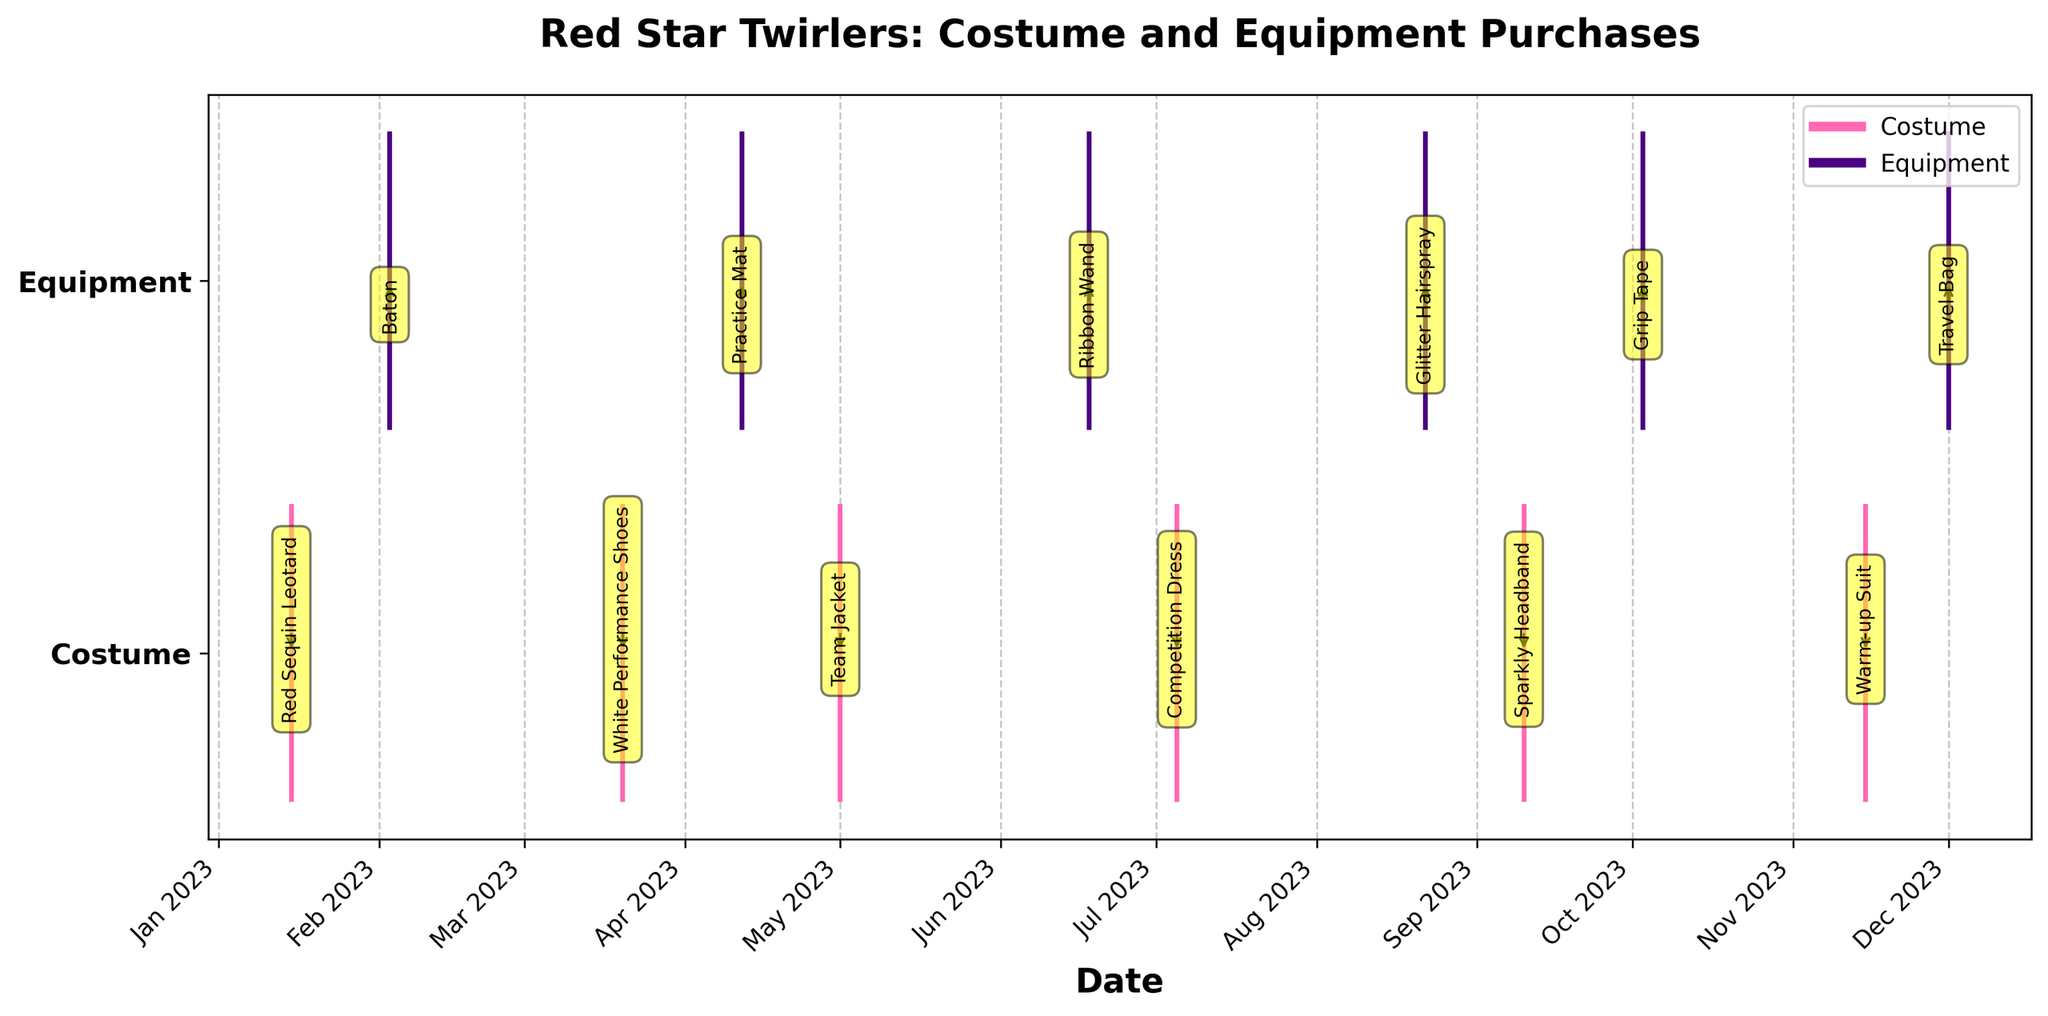What are the dates for the costume purchases? The figure shows pink vertical lines along the x-axis for costume purchases. The text annotations indicate the specific items and dates. The costume purchases occurred on January 15, March 20, May 1, July 5, September 10, and November 15.
Answer: January 15, March 20, May 1, July 5, September 10, November 15 Which category has more purchases in the year? By counting the event lines, we see there are six lines for costumes (pink) and six for equipment (purple). Both categories have an equal number of purchases.
Answer: Both have equal What is the first equipment purchased and on what date? The figure shows the earliest date for equipment purchases with a purple line at February 3. The text annotation indicates the item is a Baton.
Answer: Baton on February 3 How many purchases were made in October? The figure has one pink line (costume) and one purple line (equipment) in October. Therefore, there are exactly two purchase events in October.
Answer: 2 purchases Which month had the highest number of purchases? Both January and April have the same number of purchases, counting four time points. Each month has one purchase from the costume category (pink) and one from the equipment category (purple). Both have the highest number of purchases in the year.
Answer: January and April What equipment was purchased last, and when? The figure shows the latest recorded purchase for equipment with a purple line on December 1. The annotation indicates the item is a Travel Bag.
Answer: Travel Bag on December 1 Compare the number of purchases in the first half of the year to the second half. Which half has more purchases? The first half of the year includes January to June, with three costume purchases and three equipment purchases. The second half from July to December also has three costume purchases and three equipment purchases. Both halves have an equal number of purchases.
Answer: Both halves equal What items were purchased for costumes in the second half of the year? By looking at the pink lines and their annotations from July to December, the costume items purchased are Competition Dress, Sparkly Headband, and Warm-up Suit.
Answer: Competition Dress, Sparkly Headband, Warm-up Suit Which item was purchased on May 1? The figure shows a pink line (costume) on May 1 with the text annotation indicating the item is a Team Jacket.
Answer: Team Jacket What is the average interval between equipment purchases? Equipment purchases occurred on February 3, April 12, June 18, August 22, October 3, and December 1. Calculate the number of days between these dates and find the average:
- Interval 1: April 12 - February 3 = 68 days
- Interval 2: June 18 - April 12 = 67 days
- Interval 3: August 22 - June 18 = 65 days
- Interval 4: October 3 - August 22 = 42 days
- Interval 5: December 1 - October 3 = 59 days
Average interval: (68 + 67 + 65 + 42 + 59) / 5 = 60.2 days
Answer: 60.2 days 